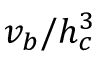Convert formula to latex. <formula><loc_0><loc_0><loc_500><loc_500>v _ { b } / h _ { c } ^ { 3 }</formula> 